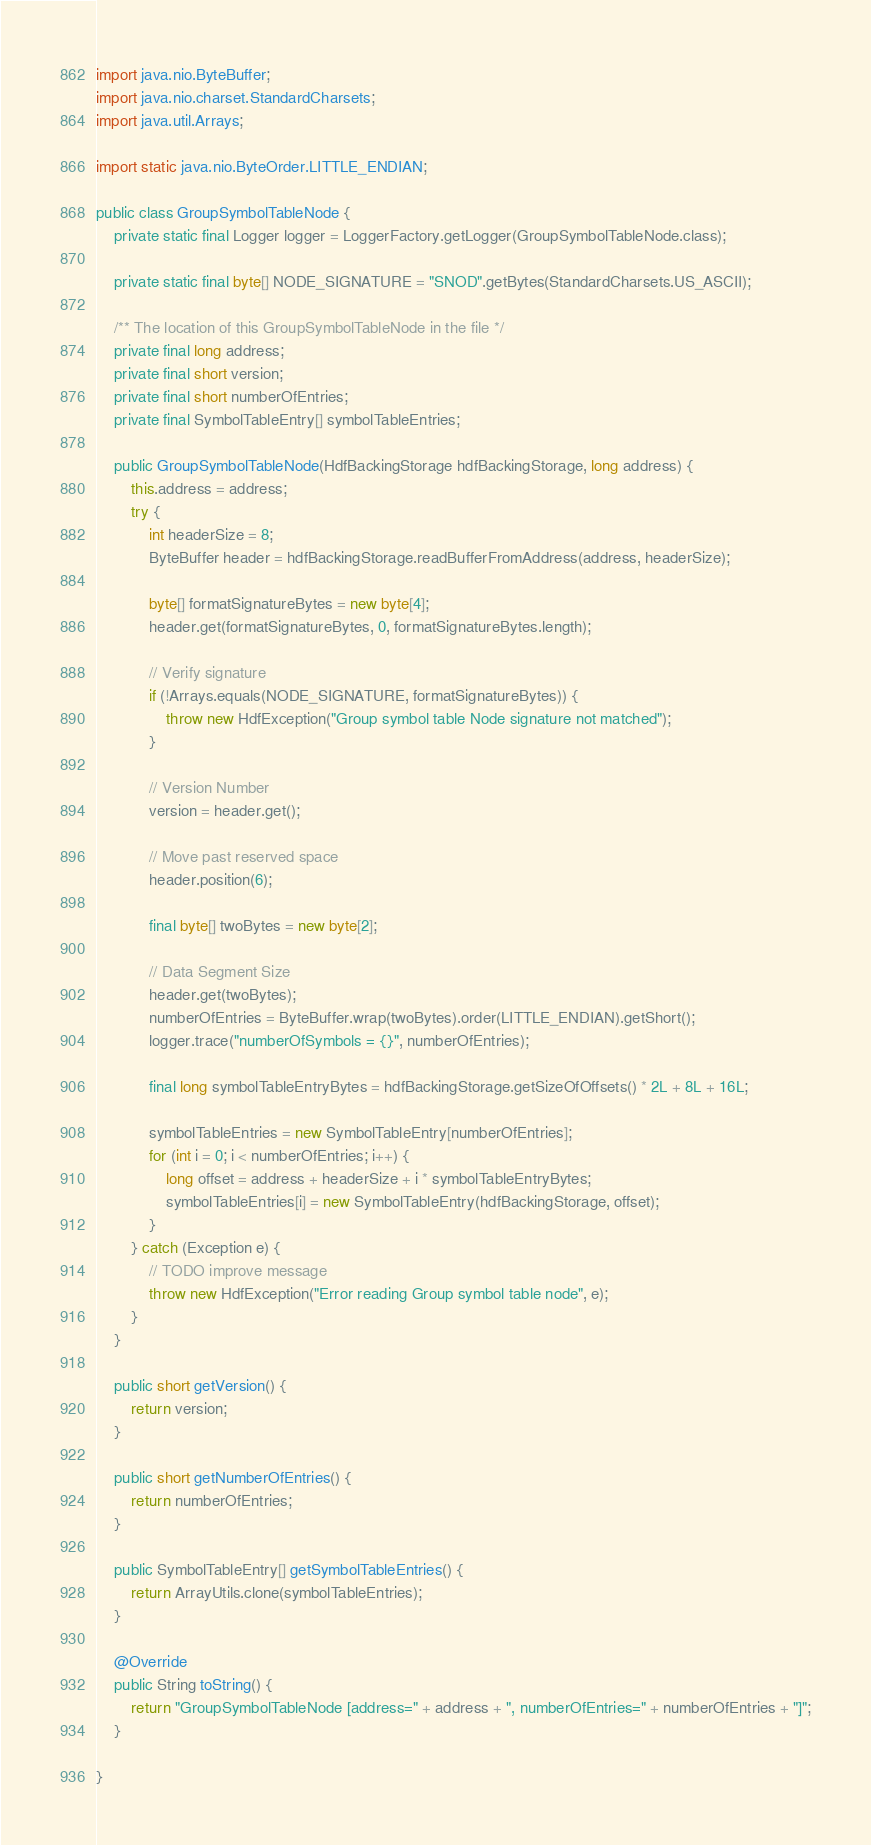Convert code to text. <code><loc_0><loc_0><loc_500><loc_500><_Java_>
import java.nio.ByteBuffer;
import java.nio.charset.StandardCharsets;
import java.util.Arrays;

import static java.nio.ByteOrder.LITTLE_ENDIAN;

public class GroupSymbolTableNode {
	private static final Logger logger = LoggerFactory.getLogger(GroupSymbolTableNode.class);

	private static final byte[] NODE_SIGNATURE = "SNOD".getBytes(StandardCharsets.US_ASCII);

	/** The location of this GroupSymbolTableNode in the file */
	private final long address;
	private final short version;
	private final short numberOfEntries;
	private final SymbolTableEntry[] symbolTableEntries;

	public GroupSymbolTableNode(HdfBackingStorage hdfBackingStorage, long address) {
		this.address = address;
		try {
			int headerSize = 8;
			ByteBuffer header = hdfBackingStorage.readBufferFromAddress(address, headerSize);

			byte[] formatSignatureBytes = new byte[4];
			header.get(formatSignatureBytes, 0, formatSignatureBytes.length);

			// Verify signature
			if (!Arrays.equals(NODE_SIGNATURE, formatSignatureBytes)) {
				throw new HdfException("Group symbol table Node signature not matched");
			}

			// Version Number
			version = header.get();

			// Move past reserved space
			header.position(6);

			final byte[] twoBytes = new byte[2];

			// Data Segment Size
			header.get(twoBytes);
			numberOfEntries = ByteBuffer.wrap(twoBytes).order(LITTLE_ENDIAN).getShort();
			logger.trace("numberOfSymbols = {}", numberOfEntries);

			final long symbolTableEntryBytes = hdfBackingStorage.getSizeOfOffsets() * 2L + 8L + 16L;

			symbolTableEntries = new SymbolTableEntry[numberOfEntries];
			for (int i = 0; i < numberOfEntries; i++) {
				long offset = address + headerSize + i * symbolTableEntryBytes;
				symbolTableEntries[i] = new SymbolTableEntry(hdfBackingStorage, offset);
			}
		} catch (Exception e) {
			// TODO improve message
			throw new HdfException("Error reading Group symbol table node", e);
		}
	}

	public short getVersion() {
		return version;
	}

	public short getNumberOfEntries() {
		return numberOfEntries;
	}

	public SymbolTableEntry[] getSymbolTableEntries() {
		return ArrayUtils.clone(symbolTableEntries);
	}

	@Override
	public String toString() {
		return "GroupSymbolTableNode [address=" + address + ", numberOfEntries=" + numberOfEntries + "]";
	}

}
</code> 